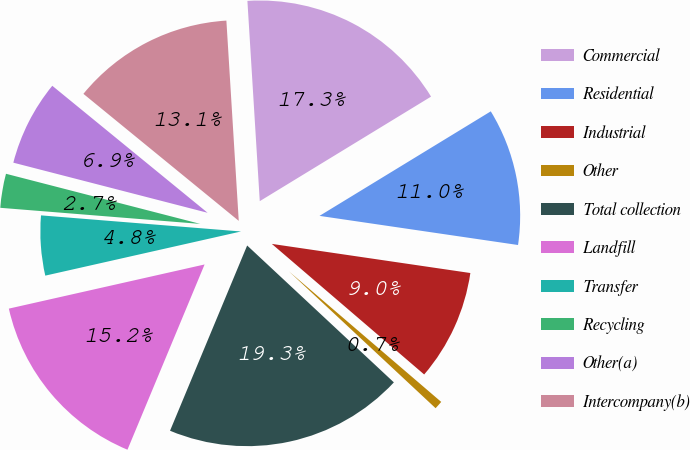<chart> <loc_0><loc_0><loc_500><loc_500><pie_chart><fcel>Commercial<fcel>Residential<fcel>Industrial<fcel>Other<fcel>Total collection<fcel>Landfill<fcel>Transfer<fcel>Recycling<fcel>Other(a)<fcel>Intercompany(b)<nl><fcel>17.26%<fcel>11.04%<fcel>8.96%<fcel>0.67%<fcel>19.33%<fcel>15.19%<fcel>4.81%<fcel>2.74%<fcel>6.89%<fcel>13.11%<nl></chart> 